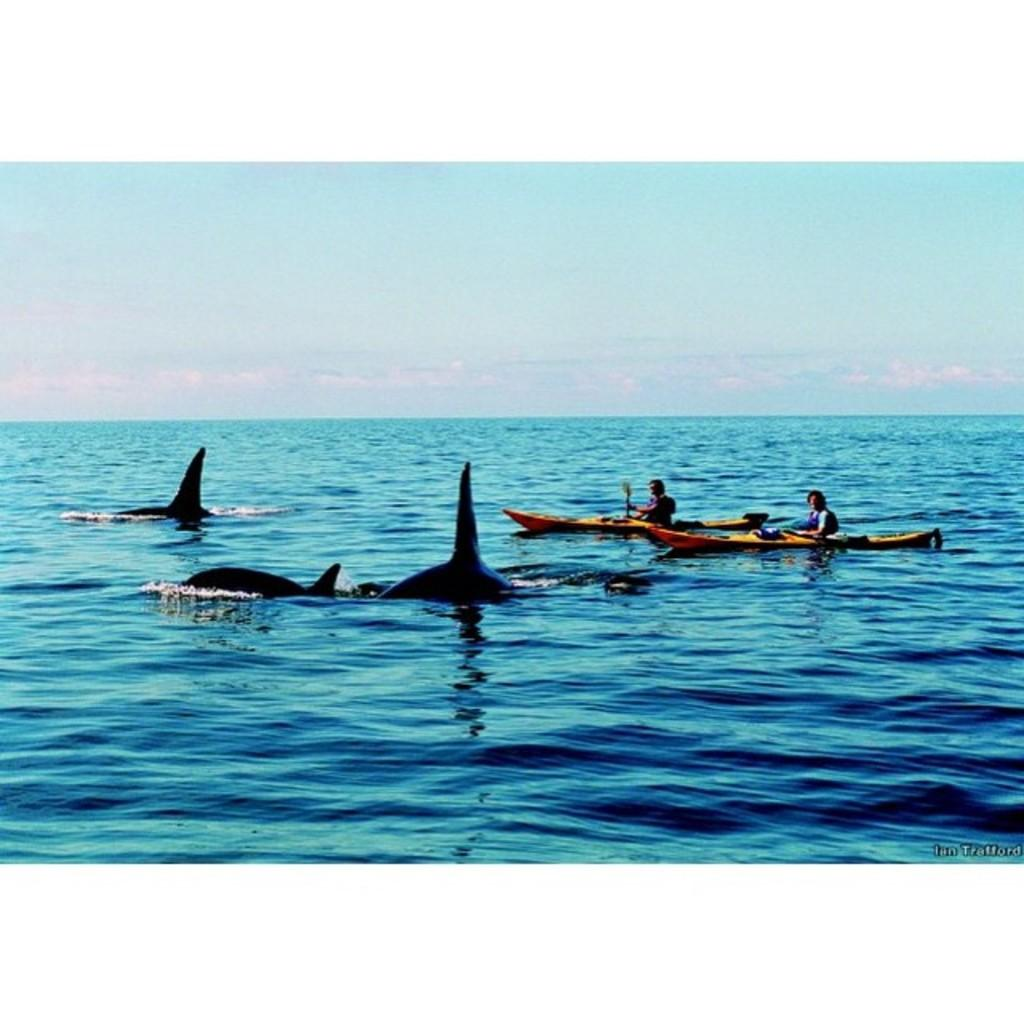What type of vehicles are in the image? There are boats with people in the image. What animals can be seen in the water? There are dolphins in the water. What part of the natural environment is visible in the image? The sky is visible in the background of the image. What can be seen in the sky? Clouds are present in the sky. What type of music can be heard coming from the boats in the image? There is no indication in the image that music is being played on the boats, so it's not possible to determine what, if any, music might be heard. 